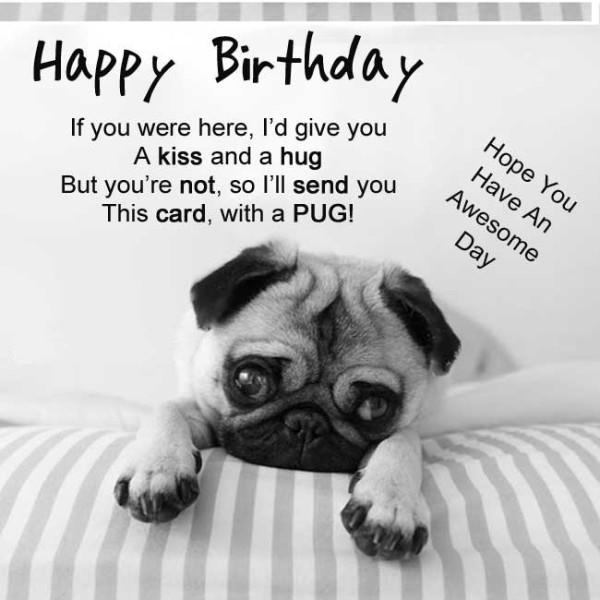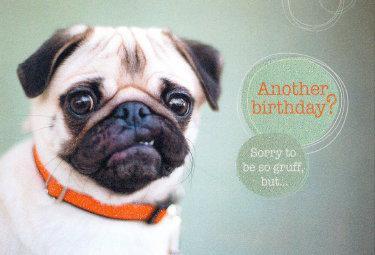The first image is the image on the left, the second image is the image on the right. Examine the images to the left and right. Is the description "One image shows a buff-beige pug with its head turned to the side and its tongue sticking out." accurate? Answer yes or no. No. The first image is the image on the left, the second image is the image on the right. Considering the images on both sides, is "One of the dogs is lying down." valid? Answer yes or no. Yes. 